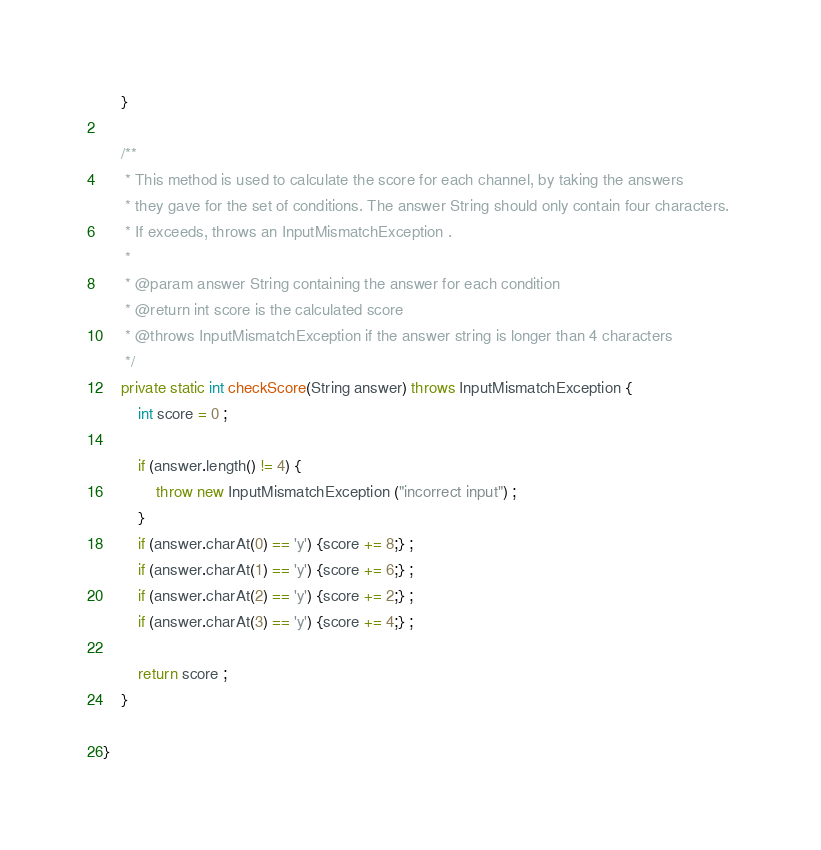<code> <loc_0><loc_0><loc_500><loc_500><_Java_>
    }

    /**
     * This method is used to calculate the score for each channel, by taking the answers 
     * they gave for the set of conditions. The answer String should only contain four characters. 
     * If exceeds, throws an InputMismatchException .
     * 
     * @param answer String containing the answer for each condition
     * @return int score is the calculated score
     * @throws InputMismatchException if the answer string is longer than 4 characters
     */
    private static int checkScore(String answer) throws InputMismatchException {
        int score = 0 ;

        if (answer.length() != 4) {
            throw new InputMismatchException ("incorrect input") ;
        }
        if (answer.charAt(0) == 'y') {score += 8;} ;
        if (answer.charAt(1) == 'y') {score += 6;} ;
        if (answer.charAt(2) == 'y') {score += 2;} ;
        if (answer.charAt(3) == 'y') {score += 4;} ;

        return score ;
    }
    
}
</code> 